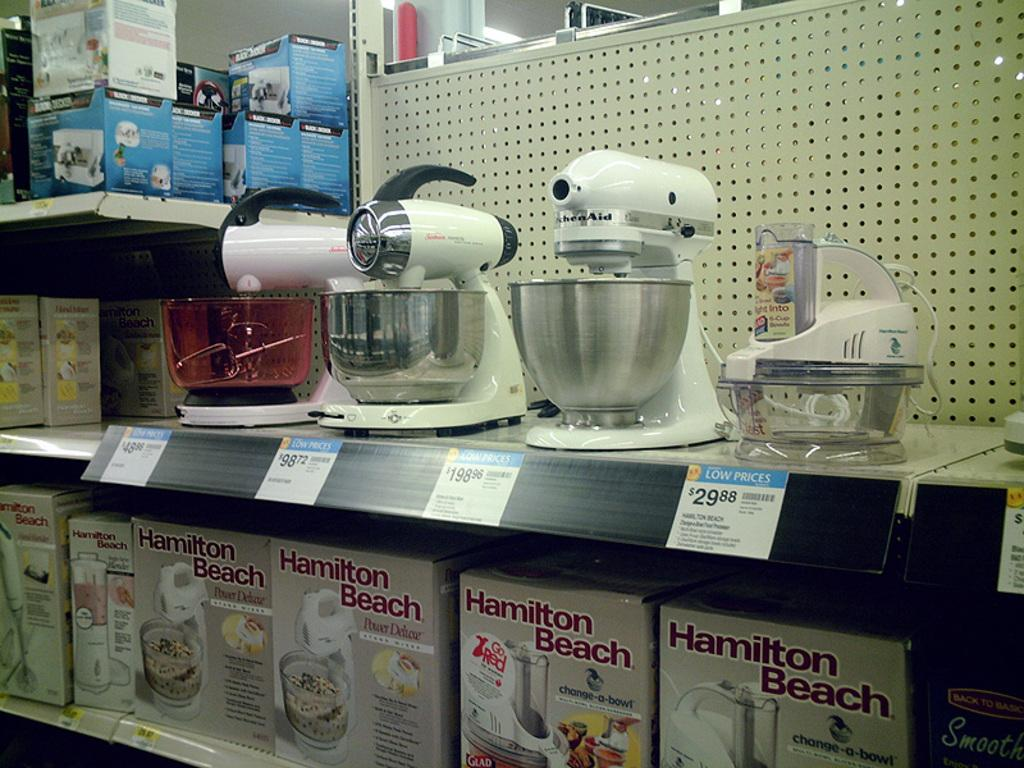Provide a one-sentence caption for the provided image. A store aisle with lots of Kitchen-Aid products with tags that say low prices. 